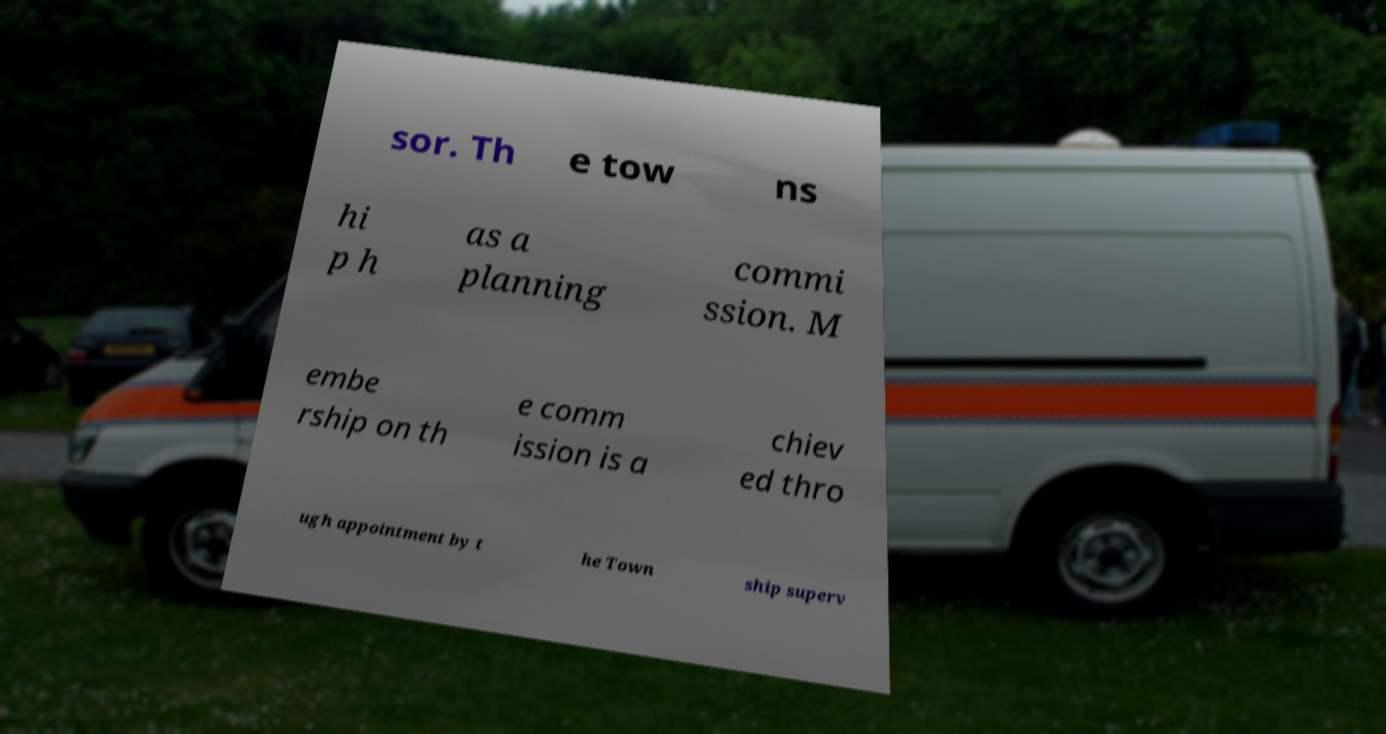Can you accurately transcribe the text from the provided image for me? sor. Th e tow ns hi p h as a planning commi ssion. M embe rship on th e comm ission is a chiev ed thro ugh appointment by t he Town ship superv 